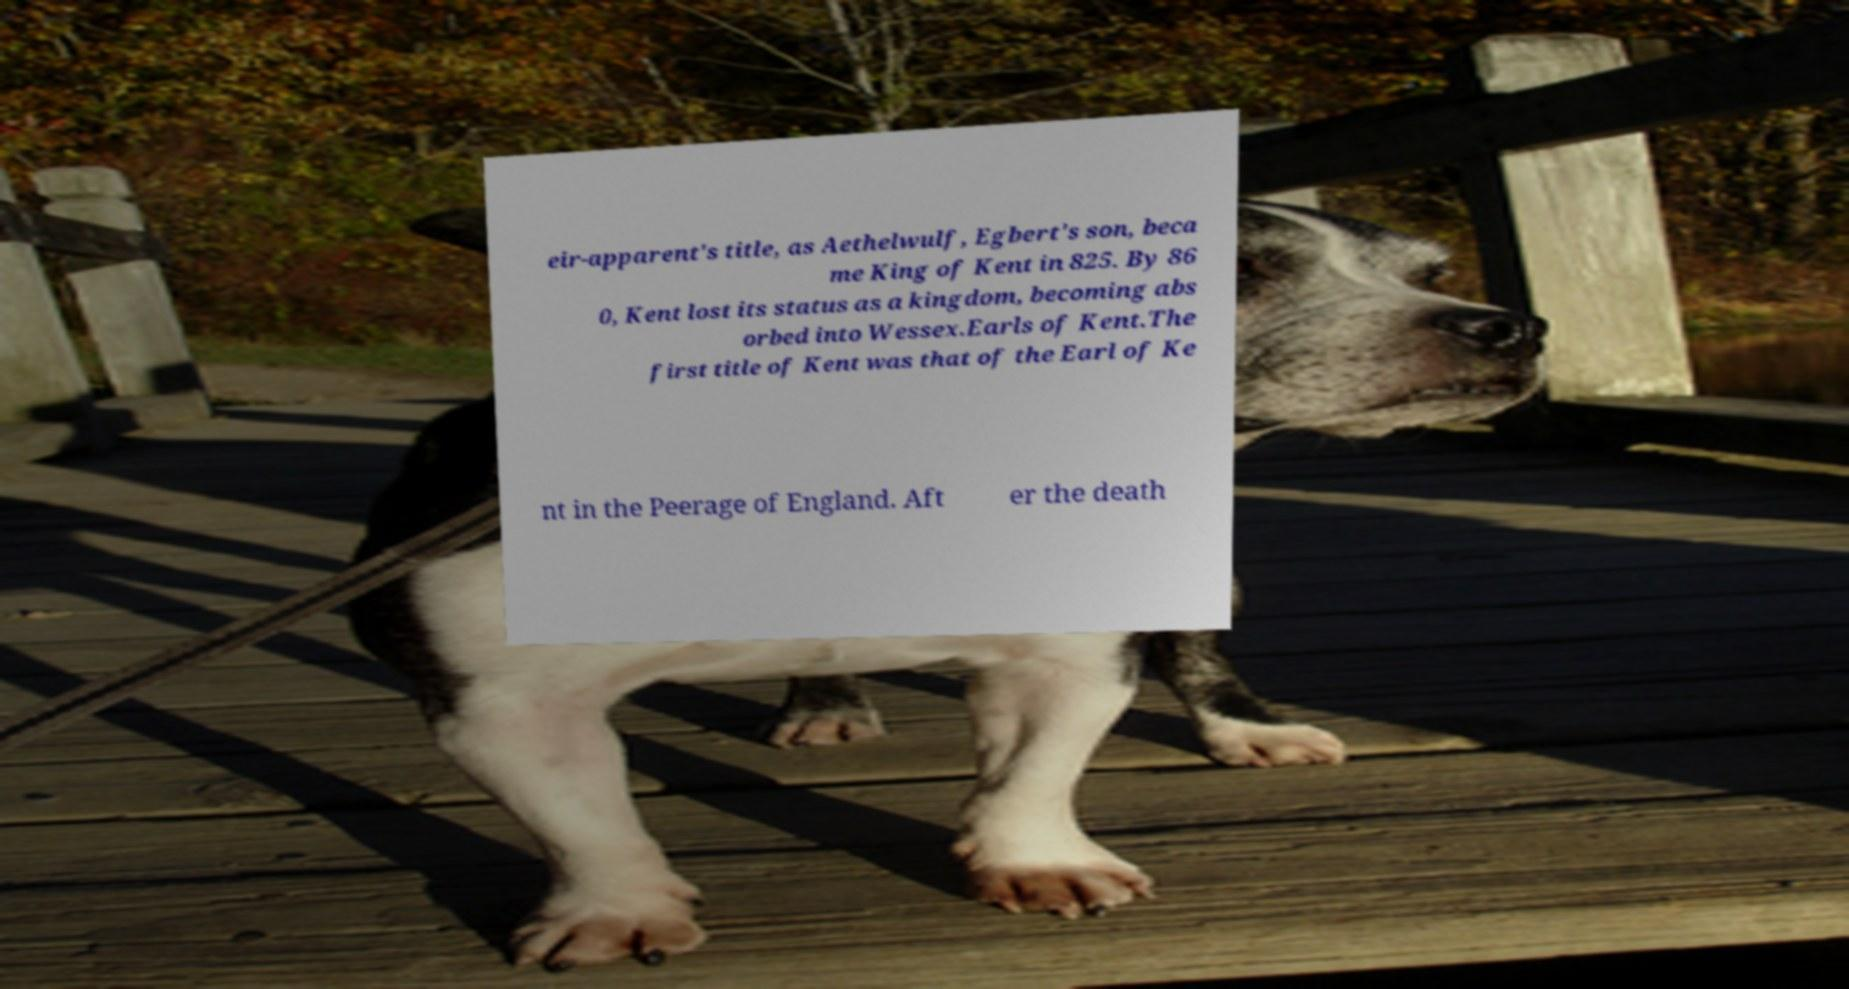There's text embedded in this image that I need extracted. Can you transcribe it verbatim? eir-apparent's title, as Aethelwulf, Egbert's son, beca me King of Kent in 825. By 86 0, Kent lost its status as a kingdom, becoming abs orbed into Wessex.Earls of Kent.The first title of Kent was that of the Earl of Ke nt in the Peerage of England. Aft er the death 